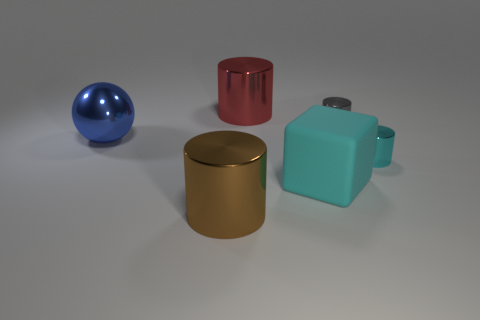Are there any large brown metallic cylinders behind the large blue metallic thing?
Your answer should be very brief. No. Are there any big red cylinders right of the big cylinder in front of the matte object?
Keep it short and to the point. Yes. There is a cylinder in front of the tiny cyan cylinder; does it have the same size as the cyan object to the right of the big cyan matte cube?
Offer a terse response. No. How many big things are either red matte objects or metal things?
Give a very brief answer. 3. The small thing left of the cyan thing on the right side of the cyan block is made of what material?
Your answer should be compact. Metal. What shape is the metal thing that is the same color as the rubber block?
Offer a very short reply. Cylinder. Is there a small thing that has the same material as the big red object?
Your answer should be very brief. Yes. Do the tiny gray thing and the small cylinder in front of the large blue ball have the same material?
Offer a terse response. Yes. What is the color of the shiny sphere that is the same size as the rubber object?
Give a very brief answer. Blue. How big is the cylinder to the left of the red thing on the right side of the blue sphere?
Your answer should be very brief. Large. 